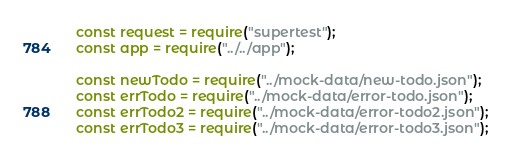Convert code to text. <code><loc_0><loc_0><loc_500><loc_500><_JavaScript_>const request = require("supertest");
const app = require("../../app");

const newTodo = require("../mock-data/new-todo.json");
const errTodo = require("../mock-data/error-todo.json");
const errTodo2 = require("../mock-data/error-todo2.json"); 
const errTodo3 = require("../mock-data/error-todo3.json");</code> 